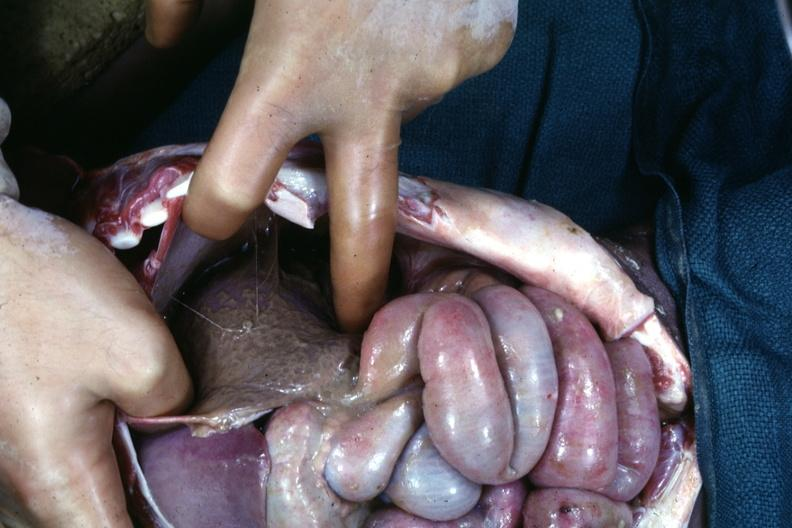s abdomen present?
Answer the question using a single word or phrase. Yes 